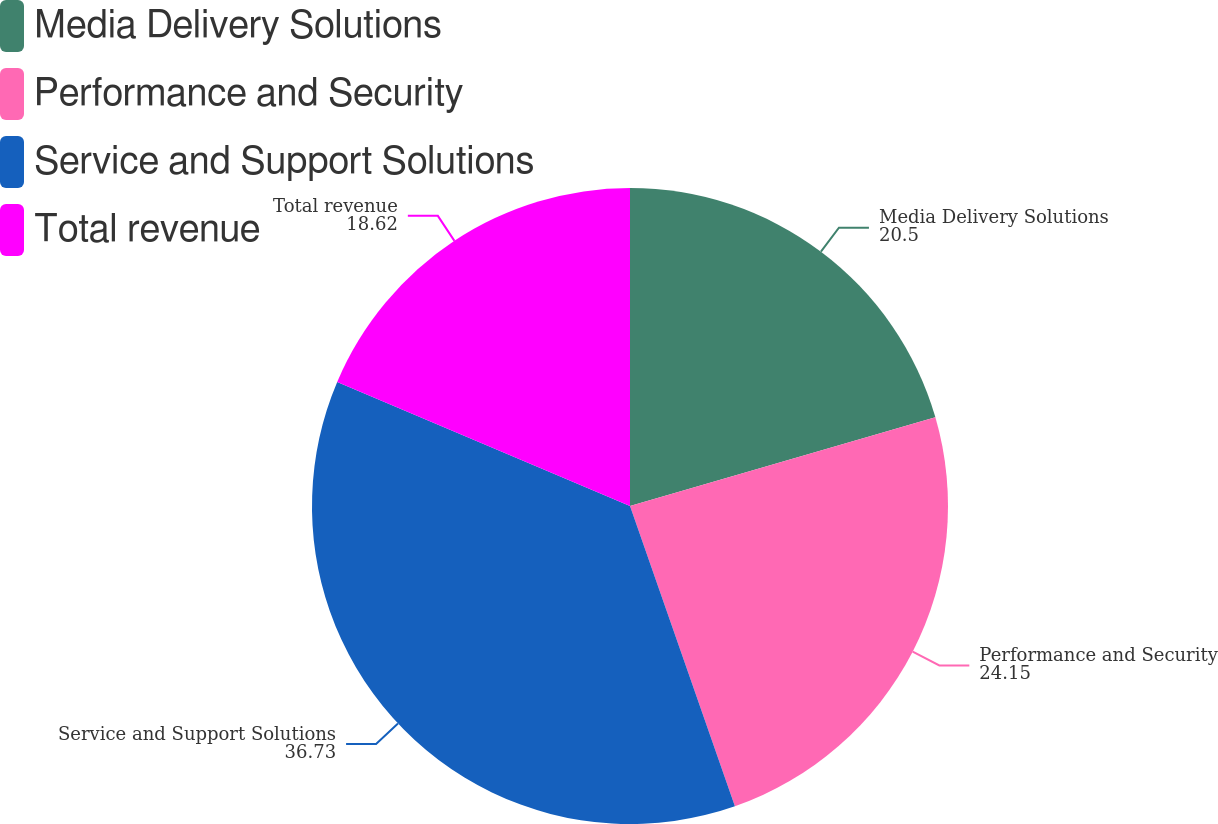<chart> <loc_0><loc_0><loc_500><loc_500><pie_chart><fcel>Media Delivery Solutions<fcel>Performance and Security<fcel>Service and Support Solutions<fcel>Total revenue<nl><fcel>20.5%<fcel>24.15%<fcel>36.73%<fcel>18.62%<nl></chart> 